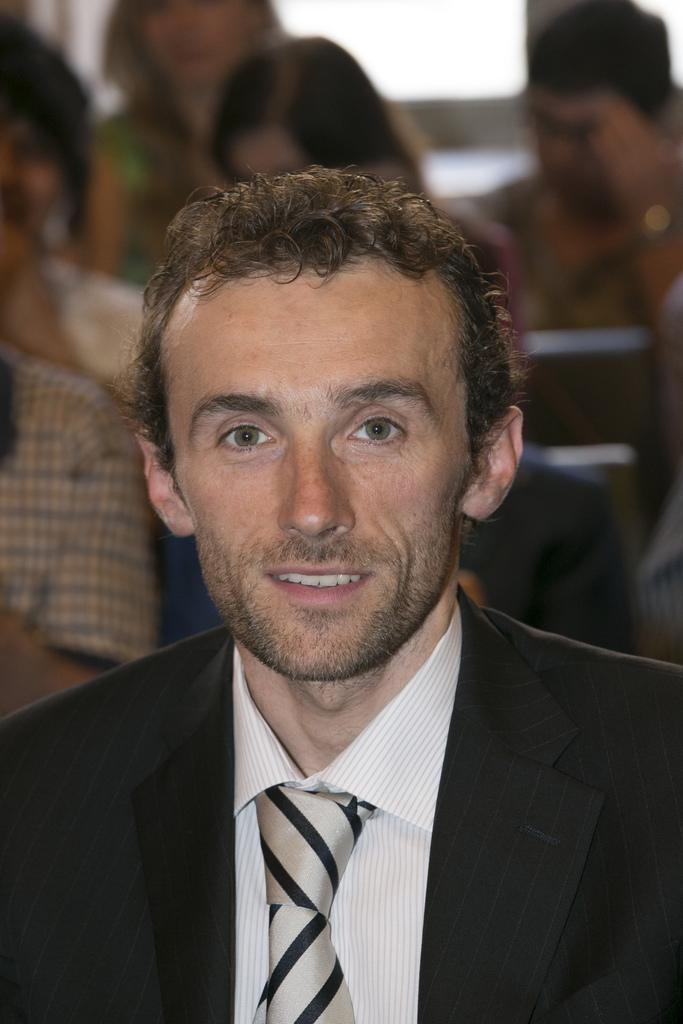Could you give a brief overview of what you see in this image? In this picture we can see a man in the black blazer and behind the man there are groups of people. 